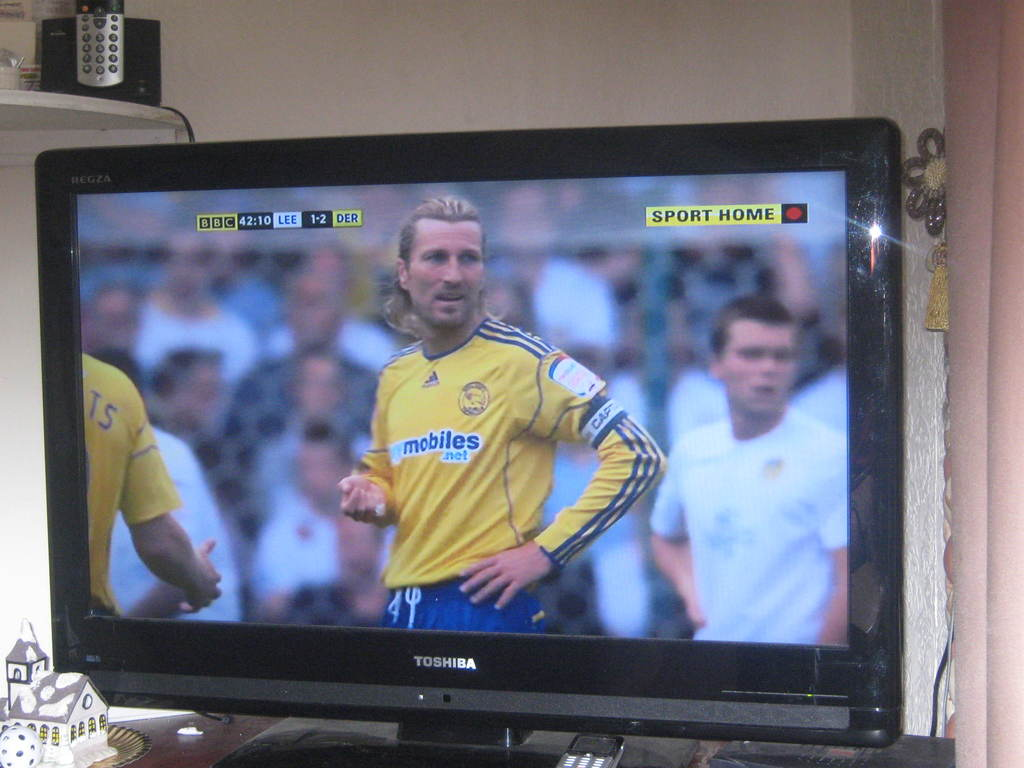What teams are shown in the match displayed on the TV? The teams shown in the match are Leeds United (in white) and Derby County (in yellow), playing a football match. 